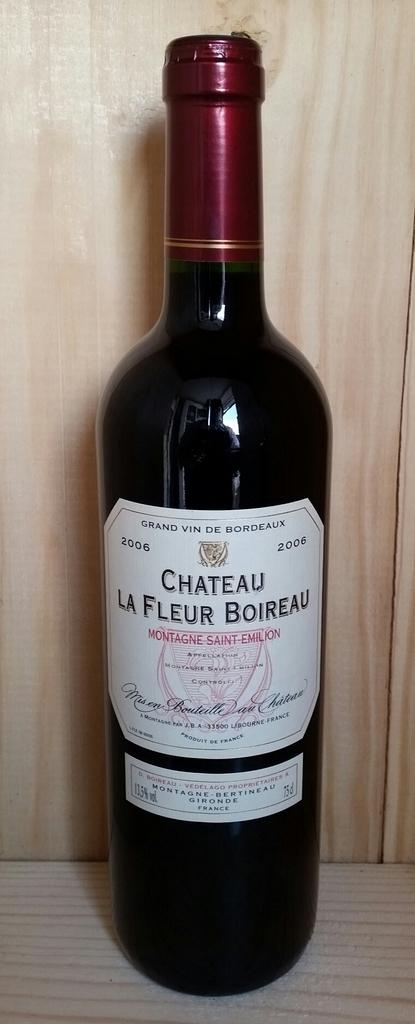<image>
Relay a brief, clear account of the picture shown. Bottle that has the year 2006 on the white label. 